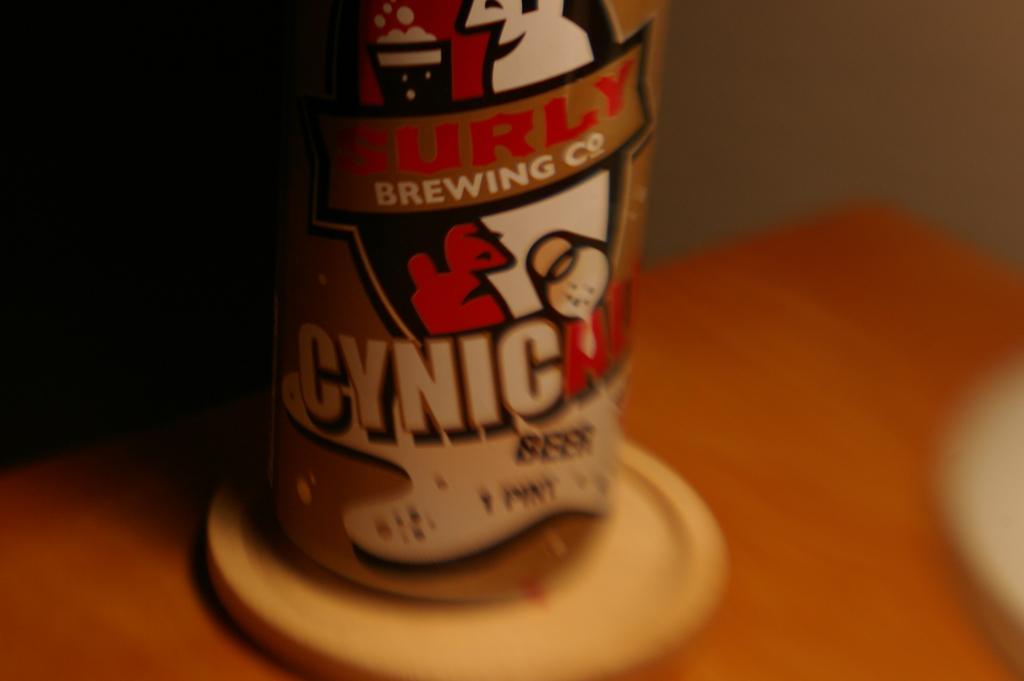How many pints in the beer?
Offer a terse response. 1. 